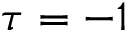<formula> <loc_0><loc_0><loc_500><loc_500>\tau = - 1</formula> 